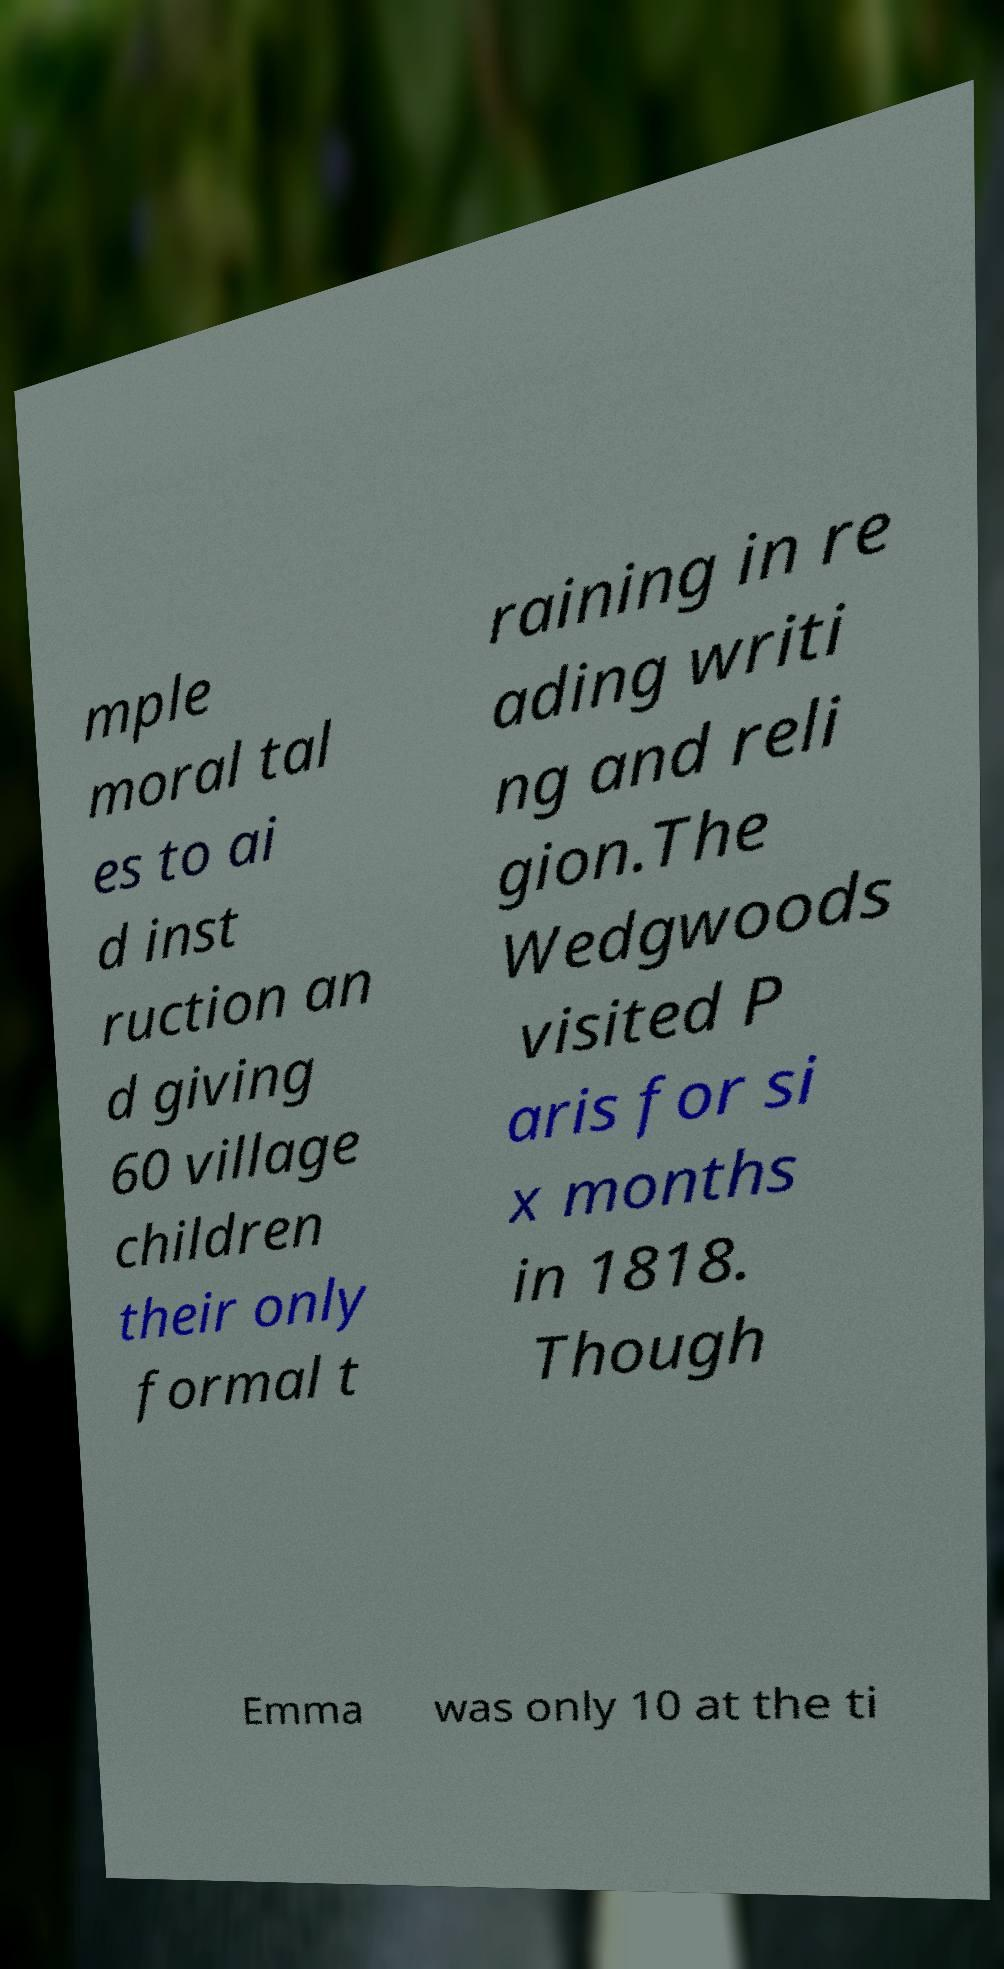Please read and relay the text visible in this image. What does it say? mple moral tal es to ai d inst ruction an d giving 60 village children their only formal t raining in re ading writi ng and reli gion.The Wedgwoods visited P aris for si x months in 1818. Though Emma was only 10 at the ti 